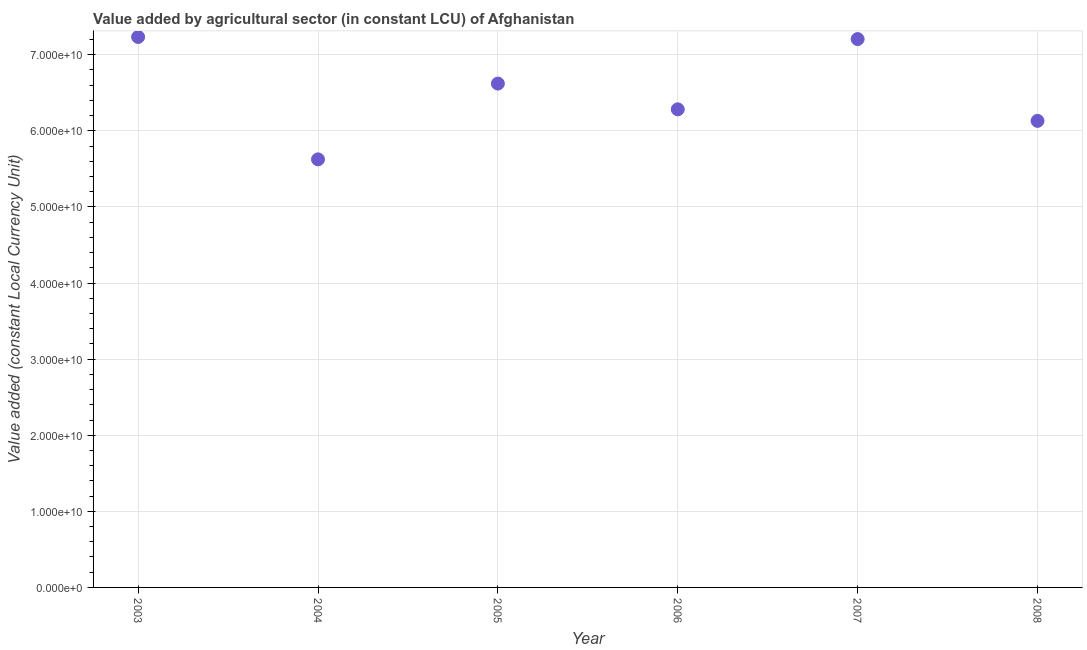What is the value added by agriculture sector in 2004?
Make the answer very short. 5.62e+1. Across all years, what is the maximum value added by agriculture sector?
Keep it short and to the point. 7.23e+1. Across all years, what is the minimum value added by agriculture sector?
Offer a very short reply. 5.62e+1. In which year was the value added by agriculture sector maximum?
Provide a short and direct response. 2003. What is the sum of the value added by agriculture sector?
Your answer should be very brief. 3.91e+11. What is the difference between the value added by agriculture sector in 2004 and 2008?
Give a very brief answer. -5.06e+09. What is the average value added by agriculture sector per year?
Offer a very short reply. 6.52e+1. What is the median value added by agriculture sector?
Give a very brief answer. 6.45e+1. What is the ratio of the value added by agriculture sector in 2003 to that in 2007?
Provide a short and direct response. 1. What is the difference between the highest and the second highest value added by agriculture sector?
Offer a very short reply. 2.80e+08. Is the sum of the value added by agriculture sector in 2004 and 2006 greater than the maximum value added by agriculture sector across all years?
Ensure brevity in your answer.  Yes. What is the difference between the highest and the lowest value added by agriculture sector?
Offer a very short reply. 1.61e+1. How many years are there in the graph?
Give a very brief answer. 6. What is the difference between two consecutive major ticks on the Y-axis?
Your response must be concise. 1.00e+1. Does the graph contain grids?
Keep it short and to the point. Yes. What is the title of the graph?
Provide a succinct answer. Value added by agricultural sector (in constant LCU) of Afghanistan. What is the label or title of the X-axis?
Keep it short and to the point. Year. What is the label or title of the Y-axis?
Make the answer very short. Value added (constant Local Currency Unit). What is the Value added (constant Local Currency Unit) in 2003?
Your answer should be very brief. 7.23e+1. What is the Value added (constant Local Currency Unit) in 2004?
Keep it short and to the point. 5.62e+1. What is the Value added (constant Local Currency Unit) in 2005?
Make the answer very short. 6.62e+1. What is the Value added (constant Local Currency Unit) in 2006?
Provide a short and direct response. 6.28e+1. What is the Value added (constant Local Currency Unit) in 2007?
Offer a terse response. 7.21e+1. What is the Value added (constant Local Currency Unit) in 2008?
Provide a succinct answer. 6.13e+1. What is the difference between the Value added (constant Local Currency Unit) in 2003 and 2004?
Keep it short and to the point. 1.61e+1. What is the difference between the Value added (constant Local Currency Unit) in 2003 and 2005?
Keep it short and to the point. 6.13e+09. What is the difference between the Value added (constant Local Currency Unit) in 2003 and 2006?
Your response must be concise. 9.51e+09. What is the difference between the Value added (constant Local Currency Unit) in 2003 and 2007?
Keep it short and to the point. 2.80e+08. What is the difference between the Value added (constant Local Currency Unit) in 2003 and 2008?
Give a very brief answer. 1.10e+1. What is the difference between the Value added (constant Local Currency Unit) in 2004 and 2005?
Make the answer very short. -9.96e+09. What is the difference between the Value added (constant Local Currency Unit) in 2004 and 2006?
Your response must be concise. -6.57e+09. What is the difference between the Value added (constant Local Currency Unit) in 2004 and 2007?
Your response must be concise. -1.58e+1. What is the difference between the Value added (constant Local Currency Unit) in 2004 and 2008?
Keep it short and to the point. -5.06e+09. What is the difference between the Value added (constant Local Currency Unit) in 2005 and 2006?
Keep it short and to the point. 3.38e+09. What is the difference between the Value added (constant Local Currency Unit) in 2005 and 2007?
Provide a short and direct response. -5.85e+09. What is the difference between the Value added (constant Local Currency Unit) in 2005 and 2008?
Offer a very short reply. 4.90e+09. What is the difference between the Value added (constant Local Currency Unit) in 2006 and 2007?
Your response must be concise. -9.23e+09. What is the difference between the Value added (constant Local Currency Unit) in 2006 and 2008?
Offer a very short reply. 1.52e+09. What is the difference between the Value added (constant Local Currency Unit) in 2007 and 2008?
Provide a short and direct response. 1.07e+1. What is the ratio of the Value added (constant Local Currency Unit) in 2003 to that in 2004?
Provide a short and direct response. 1.29. What is the ratio of the Value added (constant Local Currency Unit) in 2003 to that in 2005?
Your response must be concise. 1.09. What is the ratio of the Value added (constant Local Currency Unit) in 2003 to that in 2006?
Your response must be concise. 1.15. What is the ratio of the Value added (constant Local Currency Unit) in 2003 to that in 2007?
Your response must be concise. 1. What is the ratio of the Value added (constant Local Currency Unit) in 2003 to that in 2008?
Keep it short and to the point. 1.18. What is the ratio of the Value added (constant Local Currency Unit) in 2004 to that in 2006?
Your answer should be very brief. 0.9. What is the ratio of the Value added (constant Local Currency Unit) in 2004 to that in 2007?
Offer a very short reply. 0.78. What is the ratio of the Value added (constant Local Currency Unit) in 2004 to that in 2008?
Your response must be concise. 0.92. What is the ratio of the Value added (constant Local Currency Unit) in 2005 to that in 2006?
Give a very brief answer. 1.05. What is the ratio of the Value added (constant Local Currency Unit) in 2005 to that in 2007?
Your answer should be compact. 0.92. What is the ratio of the Value added (constant Local Currency Unit) in 2006 to that in 2007?
Provide a short and direct response. 0.87. What is the ratio of the Value added (constant Local Currency Unit) in 2007 to that in 2008?
Provide a short and direct response. 1.18. 